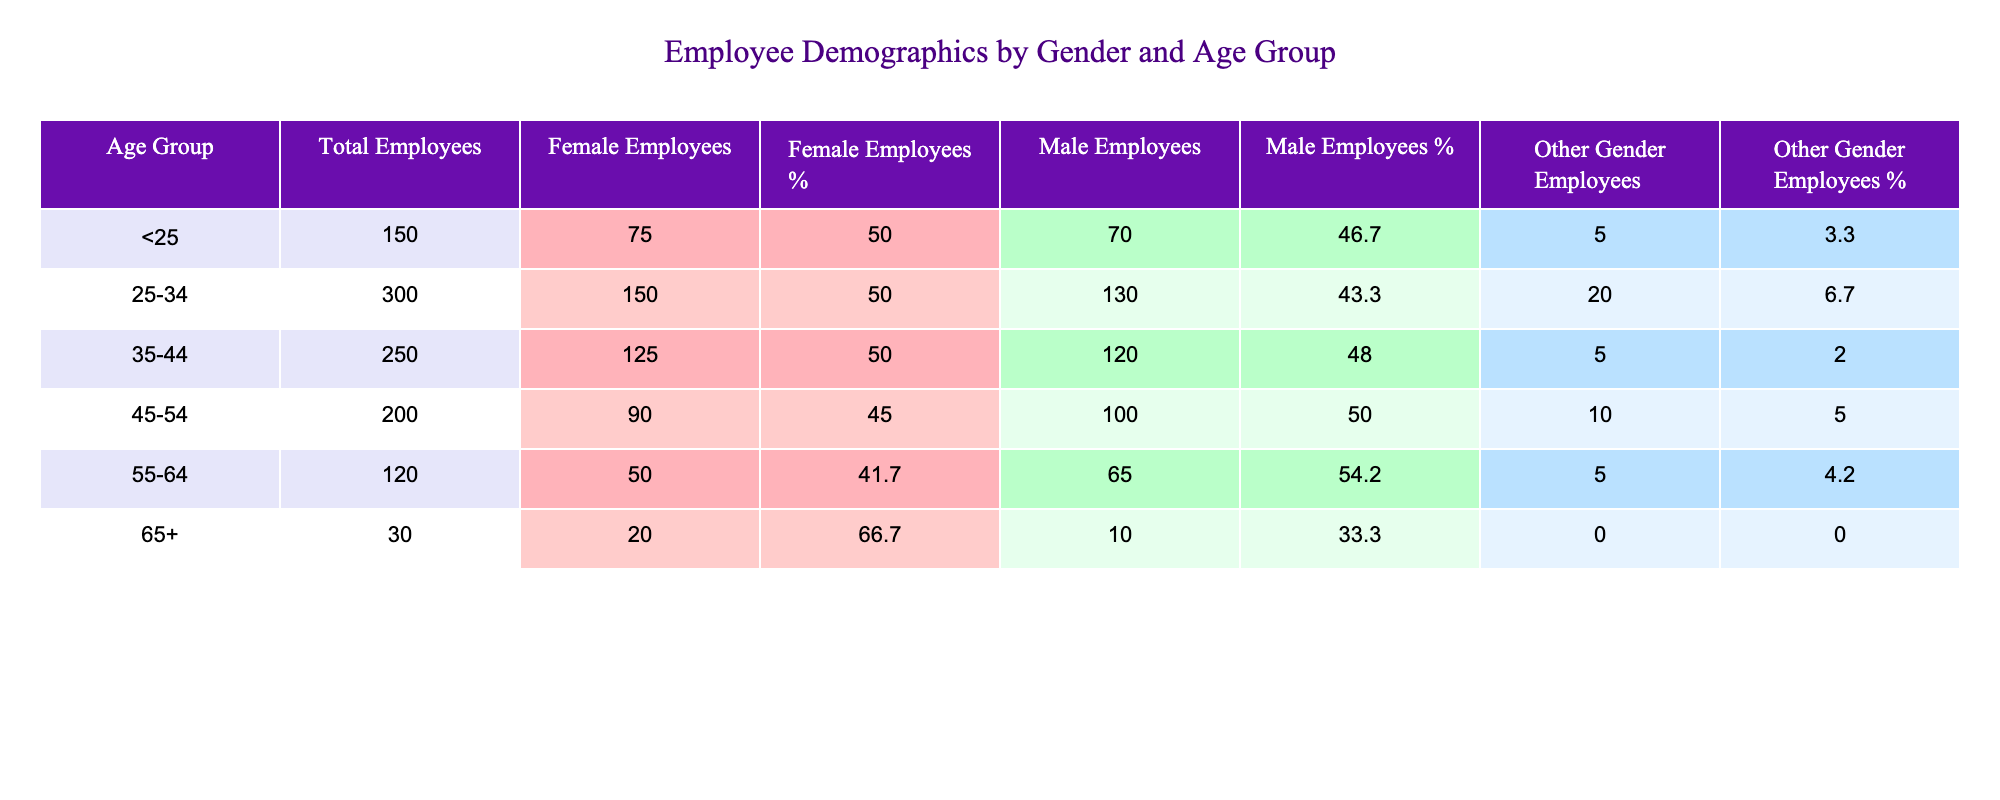What is the total number of employees in the 25-34 age group? The table shows that the total number of employees in the 25-34 age group is provided directly under the "Total Employees" column for that group. It states 300.
Answer: 300 How many female employees are there in the 45-54 age group? Referring to the row for the 45-54 age group, the number of female employees is listed as 90 under the "Female Employees" column.
Answer: 90 What percentage of employees aged 55-64 are male? To find the percentage of male employees in the 55-64 age group, look at the "Male Employees" column (65) and divide by the "Total Employees" (120). The calculation is (65/120) * 100 = 54.2%, which we can round to 54.2%.
Answer: 54.2% What is the average number of other gender employees across all age groups? We first need to sum the numbers in the "Other Gender Employees" column, which are 5, 20, 5, 10, 5, and 0. Adding these gives us 45. Then we divide this by the total number of age groups, which is 6. So, 45 / 6 = 7.5.
Answer: 7.5 Are there more male employees than female employees in the 65+ age group? In the 65+ age group, there are 10 male employees and 20 female employees. Since 10 is not more than 20, the statement is false.
Answer: No What is the total number of female employees across all age groups? To get the total female employees, we add the female workers across all age groups: 75 (under 25) + 150 (25-34) + 125 (35-44) + 90 (45-54) + 50 (55-64) + 20 (65+) = 510.
Answer: 510 Which age group has the highest percentage of female employees? To determine this, we have to calculate the percentage of female employees for each age group and find the maximum. The percentages are: 50.0% (under 25), 50.0% (25-34), 50.0% (35-44), 45.0% (45-54), 41.7% (55-64), and 66.7% (65+). The highest percentage is 66.7% in the 65+ age group.
Answer: 65+ What is the difference in the number of total employees between the 25-34 and 35-44 age groups? The total employees in the 25-34 age group is 300 and in the 35-44 age group is 250. Calculating the difference gives us 300 - 250 = 50.
Answer: 50 What is the total number of male employees in the corporation? To find the total male employees, we add the male employees from all age groups: 70 (under 25) + 130 (25-34) + 120 (35-44) + 100 (45-54) + 65 (55-64) + 10 (65+) = 495.
Answer: 495 